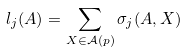Convert formula to latex. <formula><loc_0><loc_0><loc_500><loc_500>l _ { j } ( A ) = \sum _ { X \in \mathcal { A } ( p ) } \sigma _ { j } ( A , X )</formula> 